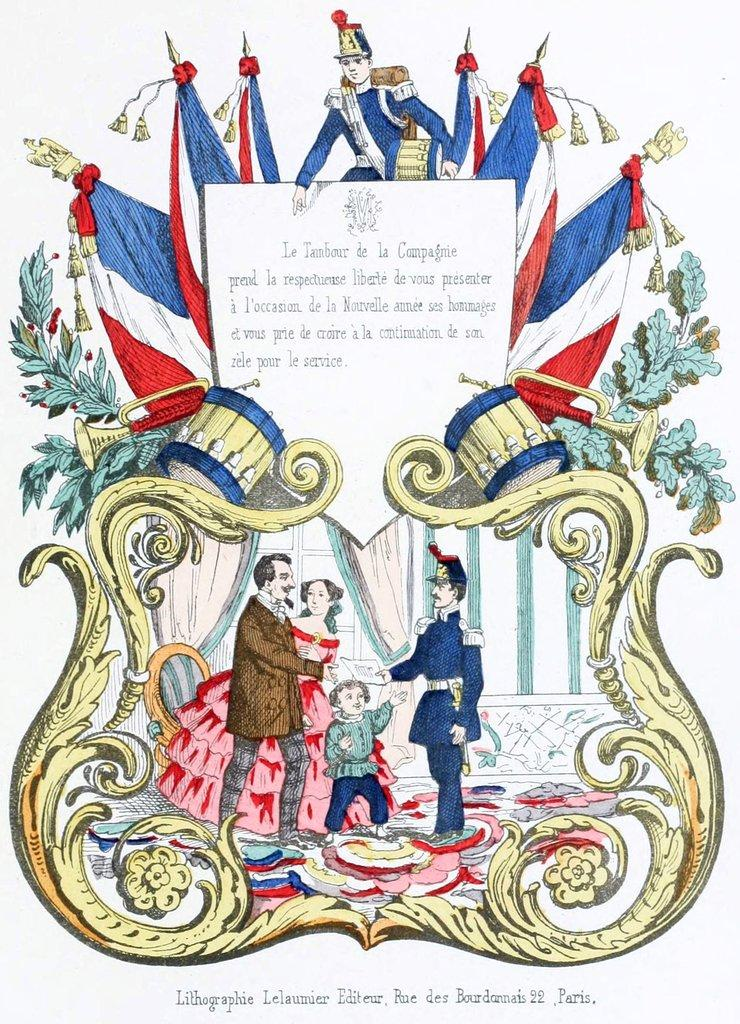What type of visual is the image? The image is a poster. What is depicted in the poster? There is a depiction of humans in the poster. What else can be seen in the poster besides the humans? There are flags, text, flowers, and musical instruments in the poster. How does the boy blow the trumpet in the poster? There is no boy present in the poster, and therefore no one is blowing a trumpet. 